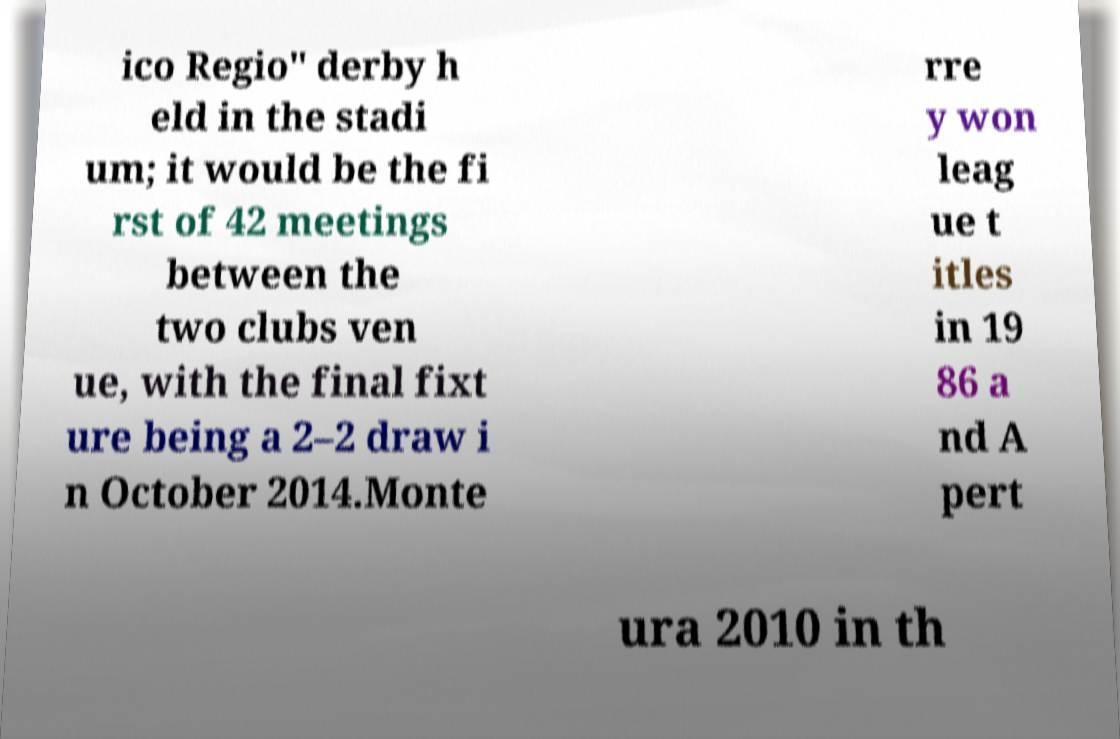There's text embedded in this image that I need extracted. Can you transcribe it verbatim? ico Regio" derby h eld in the stadi um; it would be the fi rst of 42 meetings between the two clubs ven ue, with the final fixt ure being a 2–2 draw i n October 2014.Monte rre y won leag ue t itles in 19 86 a nd A pert ura 2010 in th 